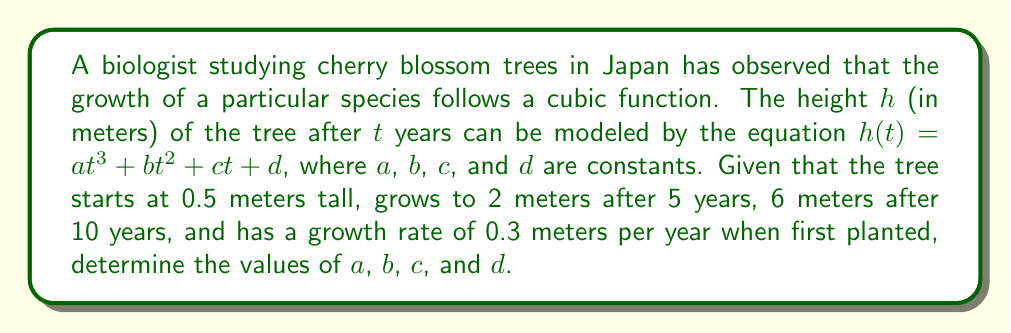What is the answer to this math problem? Let's solve this step-by-step:

1) We're given four pieces of information that we can use to create equations:
   - At $t = 0$, $h = 0.5$
   - At $t = 5$, $h = 2$
   - At $t = 10$, $h = 6$
   - At $t = 0$, $\frac{dh}{dt} = 0.3$

2) Let's create four equations using this information:

   Equation 1: $d = 0.5$ (when $t = 0$, $h = 0.5$)
   
   Equation 2: $125a + 25b + 5c + 0.5 = 2$ (when $t = 5$, $h = 2$)
   
   Equation 3: $1000a + 100b + 10c + 0.5 = 6$ (when $t = 10$, $h = 6$)
   
   Equation 4: $c = 0.3$ (the derivative of $h(t)$ at $t = 0$ is $0.3$)

3) From Equation 4, we know $c = 0.3$

4) Substituting known values into Equation 2:
   $125a + 25b + 1.5 + 0.5 = 2$
   $125a + 25b = 0$
   $5a + b = 0$ ... (Equation 5)

5) Substituting known values into Equation 3:
   $1000a + 100b + 3 + 0.5 = 6$
   $1000a + 100b = 2.5$
   $10a + b = 0.025$ ... (Equation 6)

6) Subtracting Equation 5 from Equation 6:
   $5a = 0.025$
   $a = 0.005$

7) Substituting this value of $a$ into Equation 5:
   $5(0.005) + b = 0$
   $b = -0.025$

8) We now have all our constants:
   $a = 0.005$
   $b = -0.025$
   $c = 0.3$
   $d = 0.5$
Answer: $a = 0.005$, $b = -0.025$, $c = 0.3$, $d = 0.5$ 